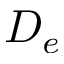<formula> <loc_0><loc_0><loc_500><loc_500>D _ { e }</formula> 